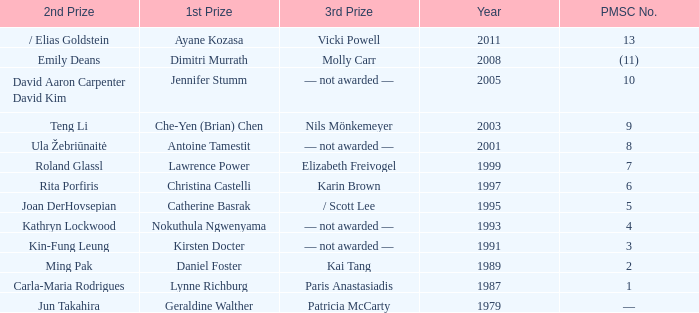Can you give me this table as a dict? {'header': ['2nd Prize', '1st Prize', '3rd Prize', 'Year', 'PMSC No.'], 'rows': [['/ Elias Goldstein', 'Ayane Kozasa', 'Vicki Powell', '2011', '13'], ['Emily Deans', 'Dimitri Murrath', 'Molly Carr', '2008', '(11)'], ['David Aaron Carpenter David Kim', 'Jennifer Stumm', '— not awarded —', '2005', '10'], ['Teng Li', 'Che-Yen (Brian) Chen', 'Nils Mönkemeyer', '2003', '9'], ['Ula Žebriūnaitė', 'Antoine Tamestit', '— not awarded —', '2001', '8'], ['Roland Glassl', 'Lawrence Power', 'Elizabeth Freivogel', '1999', '7'], ['Rita Porfiris', 'Christina Castelli', 'Karin Brown', '1997', '6'], ['Joan DerHovsepian', 'Catherine Basrak', '/ Scott Lee', '1995', '5'], ['Kathryn Lockwood', 'Nokuthula Ngwenyama', '— not awarded —', '1993', '4'], ['Kin-Fung Leung', 'Kirsten Docter', '— not awarded —', '1991', '3'], ['Ming Pak', 'Daniel Foster', 'Kai Tang', '1989', '2'], ['Carla-Maria Rodrigues', 'Lynne Richburg', 'Paris Anastasiadis', '1987', '1'], ['Jun Takahira', 'Geraldine Walther', 'Patricia McCarty', '1979', '—']]} What is the earliest year in which the 1st price went to Che-Yen (Brian) Chen? 2003.0. 